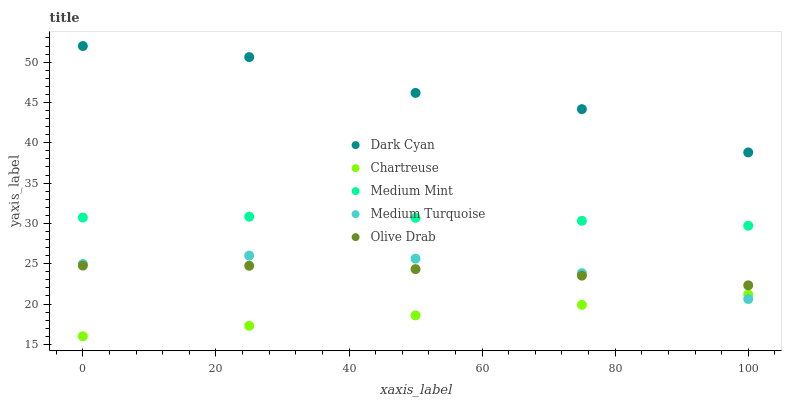Does Chartreuse have the minimum area under the curve?
Answer yes or no. Yes. Does Dark Cyan have the maximum area under the curve?
Answer yes or no. Yes. Does Medium Mint have the minimum area under the curve?
Answer yes or no. No. Does Medium Mint have the maximum area under the curve?
Answer yes or no. No. Is Chartreuse the smoothest?
Answer yes or no. Yes. Is Dark Cyan the roughest?
Answer yes or no. Yes. Is Medium Mint the smoothest?
Answer yes or no. No. Is Medium Mint the roughest?
Answer yes or no. No. Does Chartreuse have the lowest value?
Answer yes or no. Yes. Does Medium Mint have the lowest value?
Answer yes or no. No. Does Dark Cyan have the highest value?
Answer yes or no. Yes. Does Medium Mint have the highest value?
Answer yes or no. No. Is Chartreuse less than Olive Drab?
Answer yes or no. Yes. Is Dark Cyan greater than Medium Turquoise?
Answer yes or no. Yes. Does Olive Drab intersect Medium Turquoise?
Answer yes or no. Yes. Is Olive Drab less than Medium Turquoise?
Answer yes or no. No. Is Olive Drab greater than Medium Turquoise?
Answer yes or no. No. Does Chartreuse intersect Olive Drab?
Answer yes or no. No. 